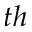Convert formula to latex. <formula><loc_0><loc_0><loc_500><loc_500>^ { t h }</formula> 